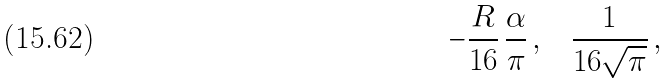Convert formula to latex. <formula><loc_0><loc_0><loc_500><loc_500>- \frac { R } { 1 6 } \, \frac { \alpha } { \pi } \, { , } \quad \frac { 1 } { 1 6 \sqrt { \pi } } \, { , }</formula> 